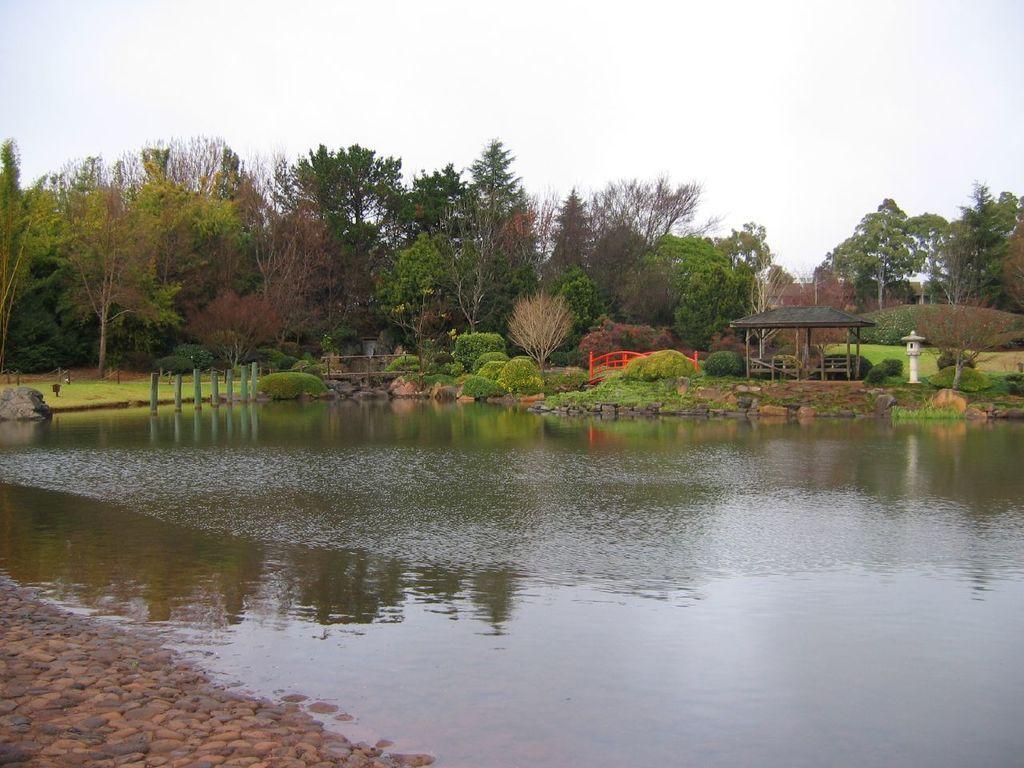How would you summarize this image in a sentence or two? Here in this picture, in the front we can see water present over a place and we can see grass covered over the ground and we can also see plants, bushes and trees present and on the right side we can see a shed present and we can see the sky is cloudy. 